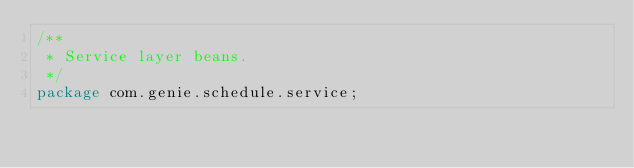<code> <loc_0><loc_0><loc_500><loc_500><_Java_>/**
 * Service layer beans.
 */
package com.genie.schedule.service;
</code> 